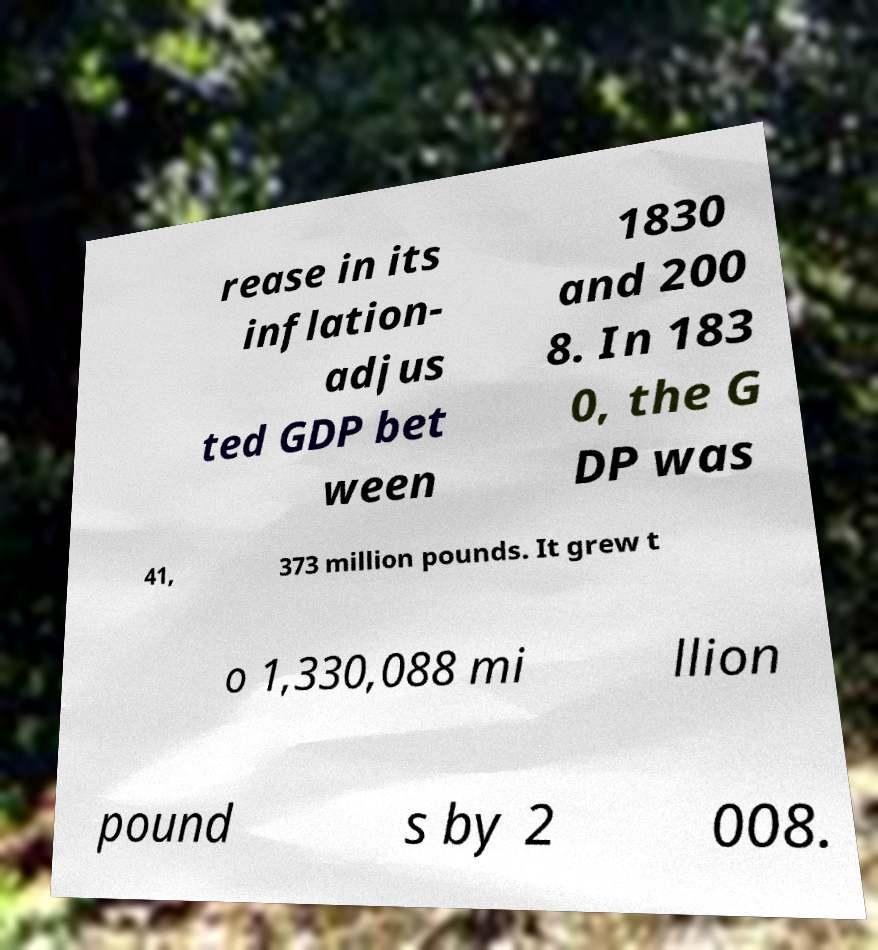Could you extract and type out the text from this image? rease in its inflation- adjus ted GDP bet ween 1830 and 200 8. In 183 0, the G DP was 41, 373 million pounds. It grew t o 1,330,088 mi llion pound s by 2 008. 